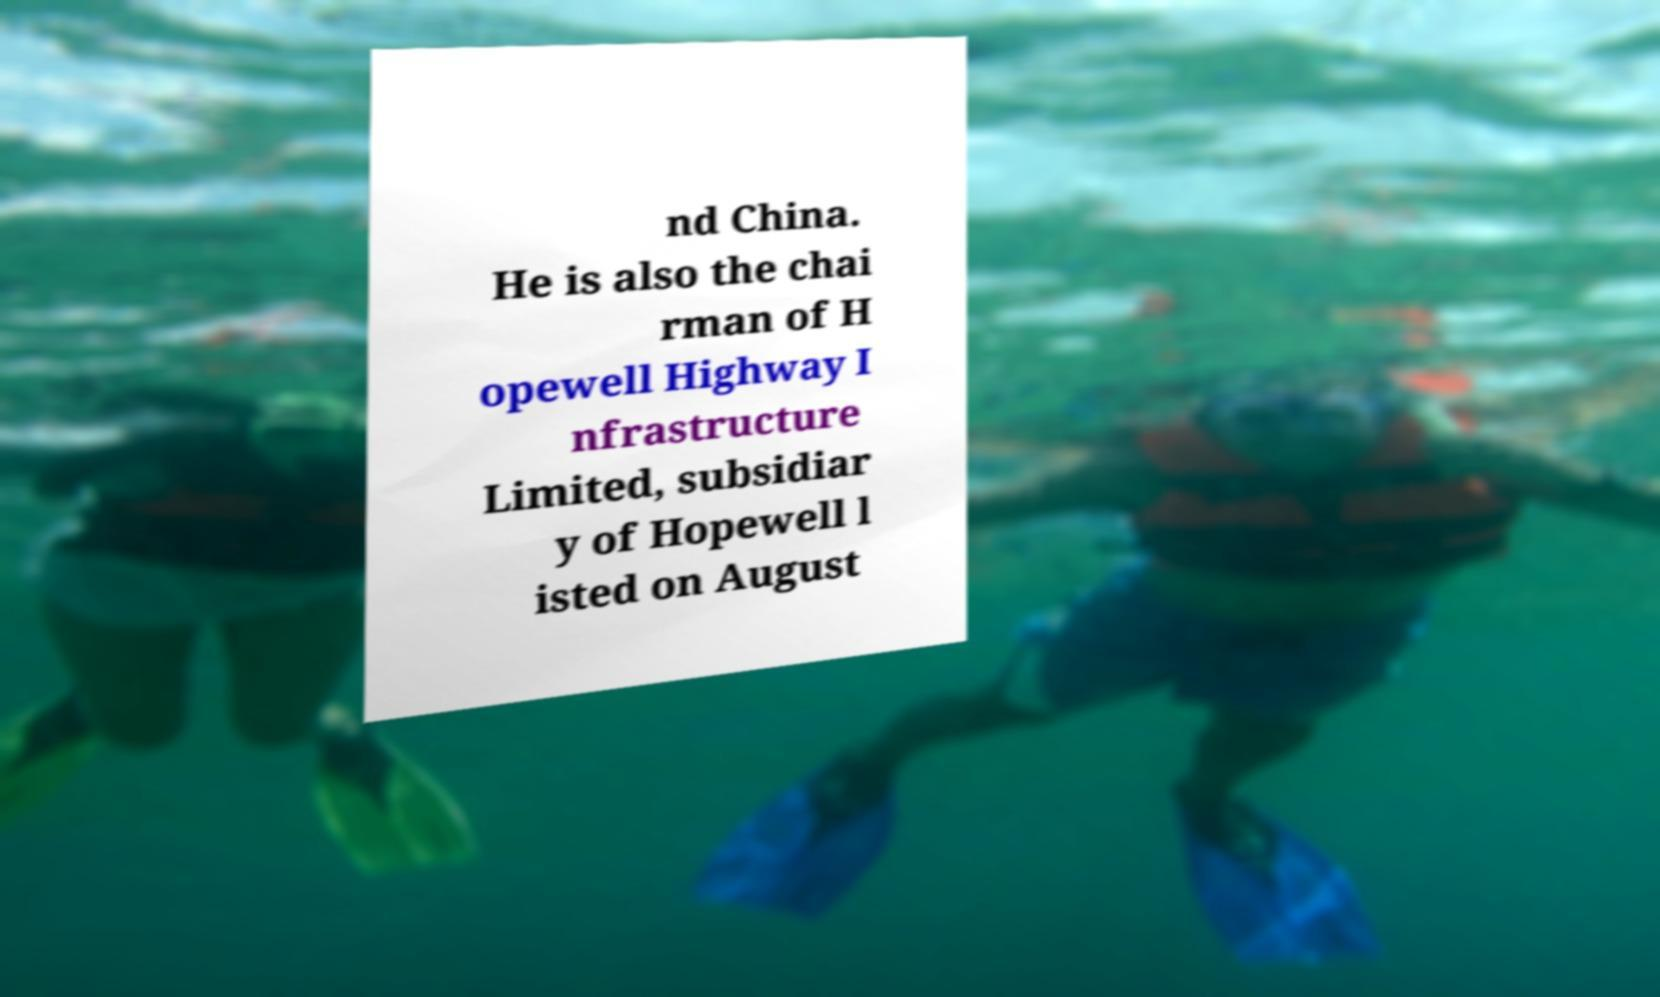There's text embedded in this image that I need extracted. Can you transcribe it verbatim? nd China. He is also the chai rman of H opewell Highway I nfrastructure Limited, subsidiar y of Hopewell l isted on August 